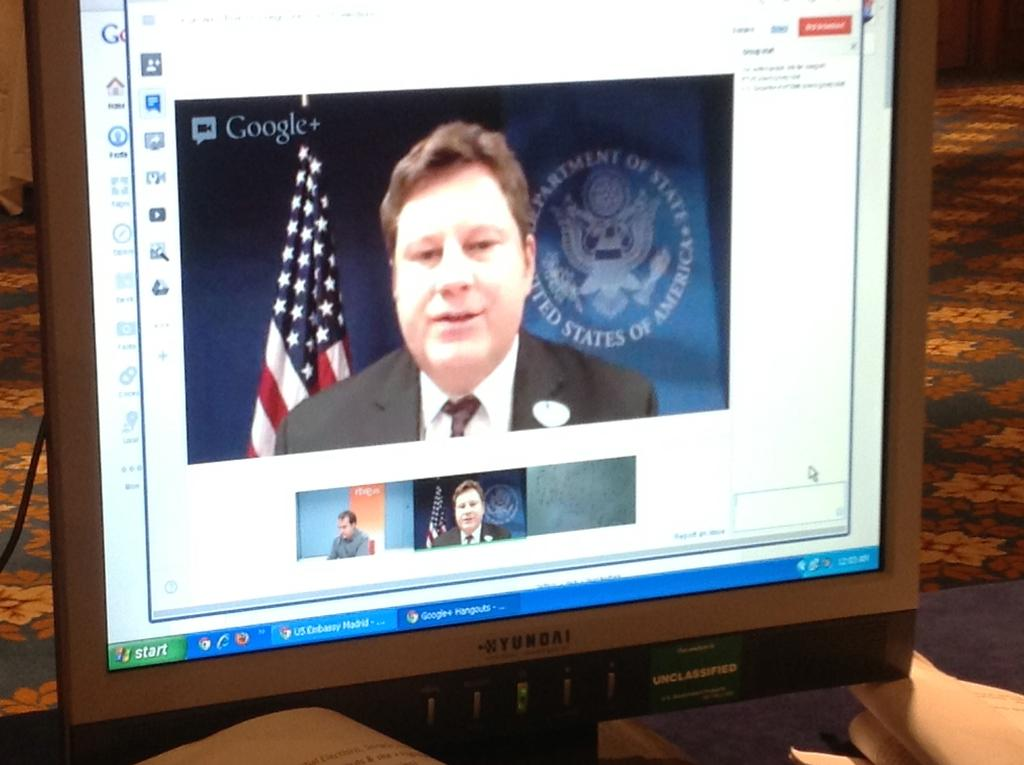<image>
Summarize the visual content of the image. A man is seen speaking with an American flag behind him on Google Plus. 